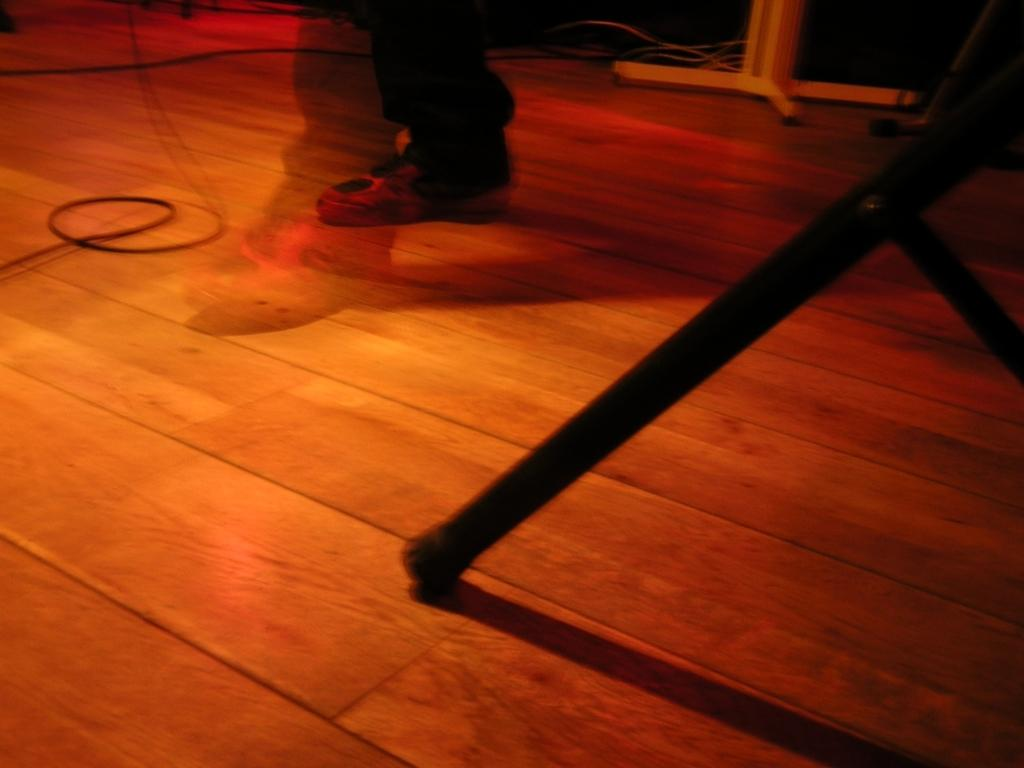What part of a person's body is visible in the image? There is a person's leg in the image. What type of surface is visible in the image? The wooden surface is visible in the image. What objects are present in the image that might be used for supporting or displaying items? There are stands in the image. What color scheme is used for the stands in the image? The stands are in black and white color. How much debt is the person in the image facing? There is no information about the person's debt in the image. What type of stone is present in the image? There is no stone present in the image. 